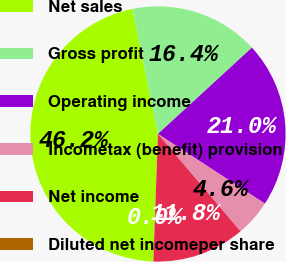Convert chart to OTSL. <chart><loc_0><loc_0><loc_500><loc_500><pie_chart><fcel>Net sales<fcel>Gross profit<fcel>Operating income<fcel>Incometax (benefit) provision<fcel>Net income<fcel>Diluted net incomeper share<nl><fcel>46.21%<fcel>16.39%<fcel>21.01%<fcel>4.62%<fcel>11.77%<fcel>0.0%<nl></chart> 